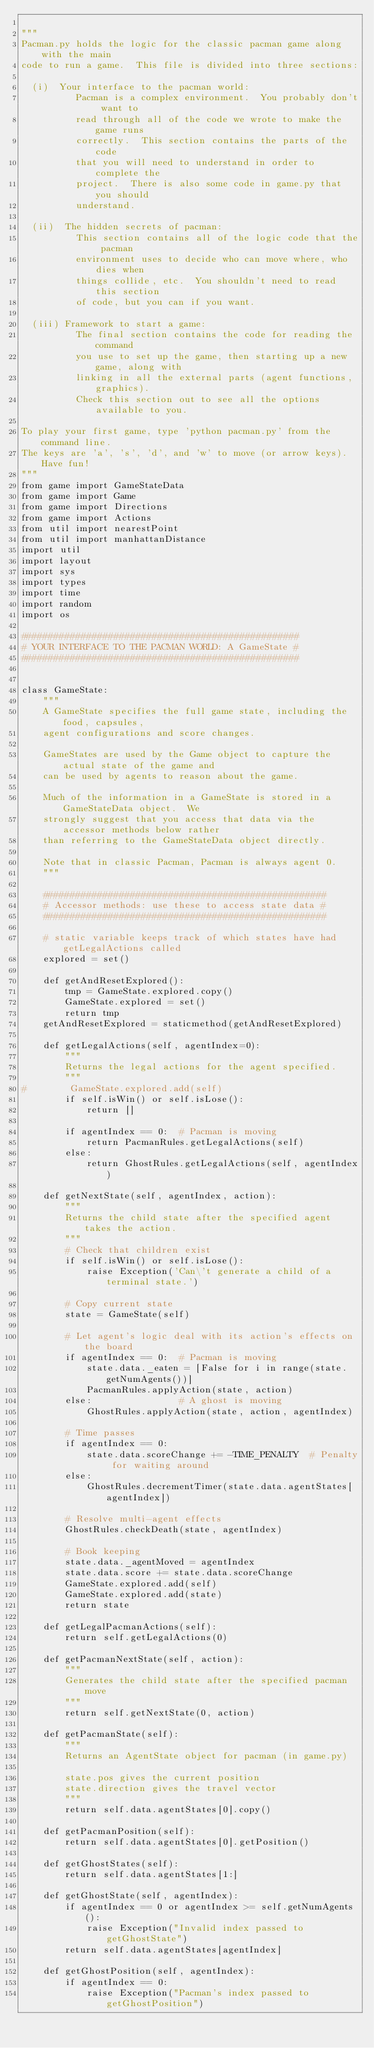<code> <loc_0><loc_0><loc_500><loc_500><_Python_>
"""
Pacman.py holds the logic for the classic pacman game along with the main
code to run a game.  This file is divided into three sections:

  (i)  Your interface to the pacman world:
          Pacman is a complex environment.  You probably don't want to
          read through all of the code we wrote to make the game runs
          correctly.  This section contains the parts of the code
          that you will need to understand in order to complete the
          project.  There is also some code in game.py that you should
          understand.

  (ii)  The hidden secrets of pacman:
          This section contains all of the logic code that the pacman
          environment uses to decide who can move where, who dies when
          things collide, etc.  You shouldn't need to read this section
          of code, but you can if you want.

  (iii) Framework to start a game:
          The final section contains the code for reading the command
          you use to set up the game, then starting up a new game, along with
          linking in all the external parts (agent functions, graphics).
          Check this section out to see all the options available to you.

To play your first game, type 'python pacman.py' from the command line.
The keys are 'a', 's', 'd', and 'w' to move (or arrow keys).  Have fun!
"""
from game import GameStateData
from game import Game
from game import Directions
from game import Actions
from util import nearestPoint
from util import manhattanDistance
import util
import layout
import sys
import types
import time
import random
import os

###################################################
# YOUR INTERFACE TO THE PACMAN WORLD: A GameState #
###################################################


class GameState:
    """
    A GameState specifies the full game state, including the food, capsules,
    agent configurations and score changes.

    GameStates are used by the Game object to capture the actual state of the game and
    can be used by agents to reason about the game.

    Much of the information in a GameState is stored in a GameStateData object.  We
    strongly suggest that you access that data via the accessor methods below rather
    than referring to the GameStateData object directly.

    Note that in classic Pacman, Pacman is always agent 0.
    """

    ####################################################
    # Accessor methods: use these to access state data #
    ####################################################

    # static variable keeps track of which states have had getLegalActions called
    explored = set()

    def getAndResetExplored():
        tmp = GameState.explored.copy()
        GameState.explored = set()
        return tmp
    getAndResetExplored = staticmethod(getAndResetExplored)

    def getLegalActions(self, agentIndex=0):
        """
        Returns the legal actions for the agent specified.
        """
#        GameState.explored.add(self)
        if self.isWin() or self.isLose():
            return []

        if agentIndex == 0:  # Pacman is moving
            return PacmanRules.getLegalActions(self)
        else:
            return GhostRules.getLegalActions(self, agentIndex)

    def getNextState(self, agentIndex, action):
        """
        Returns the child state after the specified agent takes the action.
        """
        # Check that children exist
        if self.isWin() or self.isLose():
            raise Exception('Can\'t generate a child of a terminal state.')

        # Copy current state
        state = GameState(self)

        # Let agent's logic deal with its action's effects on the board
        if agentIndex == 0:  # Pacman is moving
            state.data._eaten = [False for i in range(state.getNumAgents())]
            PacmanRules.applyAction(state, action)
        else:                # A ghost is moving
            GhostRules.applyAction(state, action, agentIndex)

        # Time passes
        if agentIndex == 0:
            state.data.scoreChange += -TIME_PENALTY  # Penalty for waiting around
        else:
            GhostRules.decrementTimer(state.data.agentStates[agentIndex])

        # Resolve multi-agent effects
        GhostRules.checkDeath(state, agentIndex)

        # Book keeping
        state.data._agentMoved = agentIndex
        state.data.score += state.data.scoreChange
        GameState.explored.add(self)
        GameState.explored.add(state)
        return state

    def getLegalPacmanActions(self):
        return self.getLegalActions(0)

    def getPacmanNextState(self, action):
        """
        Generates the child state after the specified pacman move
        """
        return self.getNextState(0, action)

    def getPacmanState(self):
        """
        Returns an AgentState object for pacman (in game.py)

        state.pos gives the current position
        state.direction gives the travel vector
        """
        return self.data.agentStates[0].copy()

    def getPacmanPosition(self):
        return self.data.agentStates[0].getPosition()

    def getGhostStates(self):
        return self.data.agentStates[1:]

    def getGhostState(self, agentIndex):
        if agentIndex == 0 or agentIndex >= self.getNumAgents():
            raise Exception("Invalid index passed to getGhostState")
        return self.data.agentStates[agentIndex]

    def getGhostPosition(self, agentIndex):
        if agentIndex == 0:
            raise Exception("Pacman's index passed to getGhostPosition")</code> 